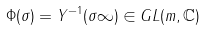Convert formula to latex. <formula><loc_0><loc_0><loc_500><loc_500>\Phi ( \sigma ) = Y ^ { - 1 } ( \sigma \infty ) \in G L ( m , { \mathbb { C } } )</formula> 